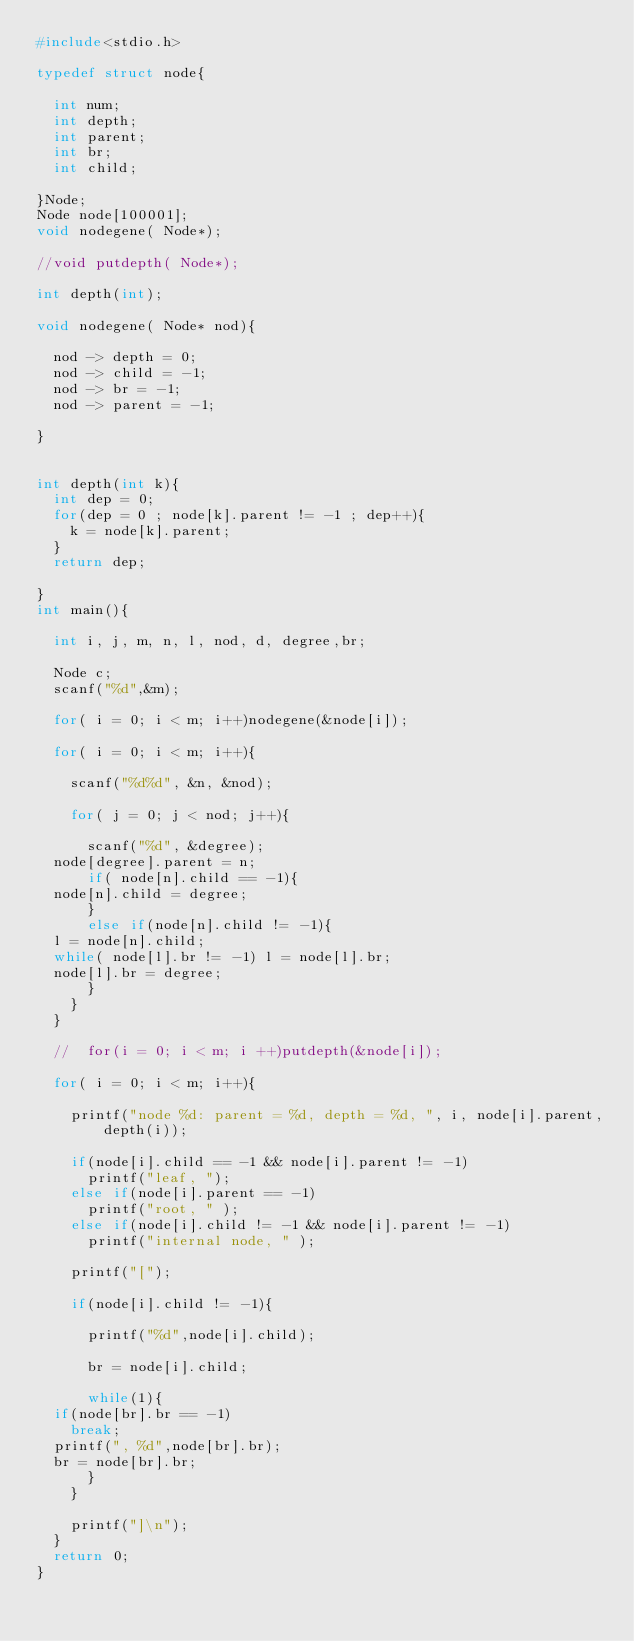Convert code to text. <code><loc_0><loc_0><loc_500><loc_500><_C_>#include<stdio.h>

typedef struct node{

  int num;
  int depth;
  int parent;
  int br;
  int child;

}Node;
Node node[100001];
void nodegene( Node*);

//void putdepth( Node*);

int depth(int);

void nodegene( Node* nod){

  nod -> depth = 0;
  nod -> child = -1;
  nod -> br = -1;
  nod -> parent = -1;

}


int depth(int k){
  int dep = 0;
  for(dep = 0 ; node[k].parent != -1 ; dep++){
    k = node[k].parent;
  }
  return dep;

}
int main(){

  int i, j, m, n, l, nod, d, degree,br;

  Node c;
  scanf("%d",&m);

  for( i = 0; i < m; i++)nodegene(&node[i]);
  
  for( i = 0; i < m; i++){

    scanf("%d%d", &n, &nod);

    for( j = 0; j < nod; j++){

      scanf("%d", &degree);
	node[degree].parent = n;
      if( node[n].child == -1){
	node[n].child = degree;
      }
      else if(node[n].child != -1){
	l = node[n].child;
	while( node[l].br != -1) l = node[l].br;
	node[l].br = degree;
      }
    }
  }

  //  for(i = 0; i < m; i ++)putdepth(&node[i]);

  for( i = 0; i < m; i++){

    printf("node %d: parent = %d, depth = %d, ", i, node[i].parent,depth(i));

    if(node[i].child == -1 && node[i].parent != -1)
      printf("leaf, ");
    else if(node[i].parent == -1)
      printf("root, " );
    else if(node[i].child != -1 && node[i].parent != -1)
      printf("internal node, " );

    printf("[");

    if(node[i].child != -1){

      printf("%d",node[i].child);

      br = node[i].child;

      while(1){
	if(node[br].br == -1)
	  break;
	printf(", %d",node[br].br);
	br = node[br].br;
      }
    }

    printf("]\n");
  }
  return 0;
}</code> 